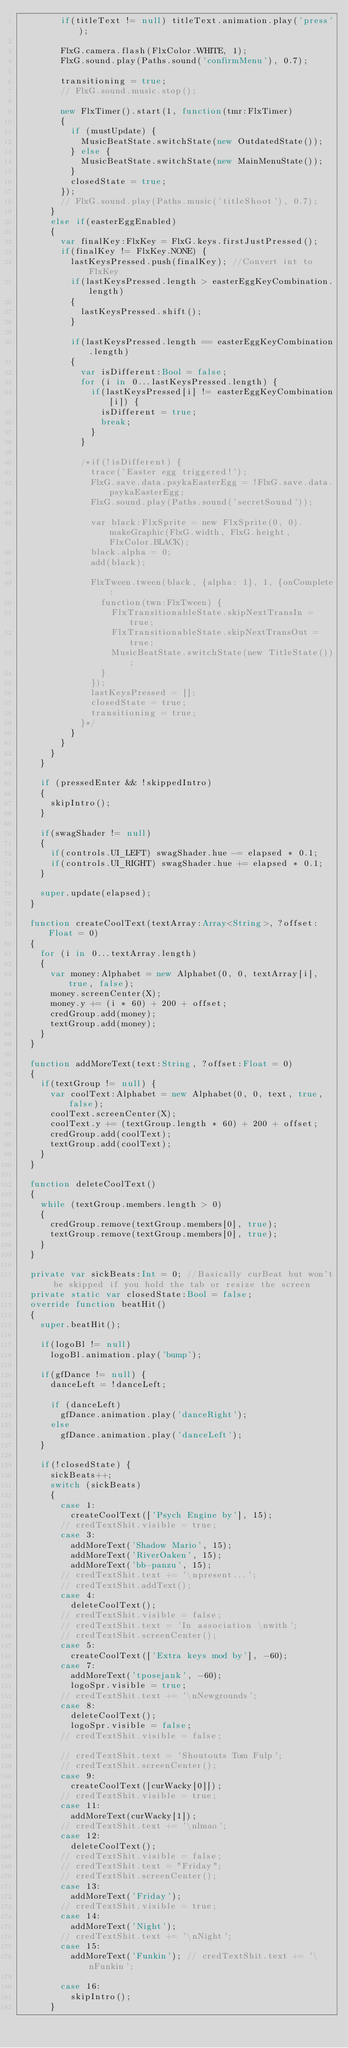<code> <loc_0><loc_0><loc_500><loc_500><_Haxe_>				if(titleText != null) titleText.animation.play('press');

				FlxG.camera.flash(FlxColor.WHITE, 1);
				FlxG.sound.play(Paths.sound('confirmMenu'), 0.7);

				transitioning = true;
				// FlxG.sound.music.stop();

				new FlxTimer().start(1, function(tmr:FlxTimer)
				{
					if (mustUpdate) {
						MusicBeatState.switchState(new OutdatedState());
					} else {
						MusicBeatState.switchState(new MainMenuState());
					}
					closedState = true;
				});
				// FlxG.sound.play(Paths.music('titleShoot'), 0.7);
			}
			else if(easterEggEnabled)
			{
				var finalKey:FlxKey = FlxG.keys.firstJustPressed();
				if(finalKey != FlxKey.NONE) {
					lastKeysPressed.push(finalKey); //Convert int to FlxKey
					if(lastKeysPressed.length > easterEggKeyCombination.length)
					{
						lastKeysPressed.shift();
					}
					
					if(lastKeysPressed.length == easterEggKeyCombination.length)
					{
						var isDifferent:Bool = false;
						for (i in 0...lastKeysPressed.length) {
							if(lastKeysPressed[i] != easterEggKeyCombination[i]) {
								isDifferent = true;
								break;
							}
						}

						/*if(!isDifferent) {
							trace('Easter egg triggered!');
							FlxG.save.data.psykaEasterEgg = !FlxG.save.data.psykaEasterEgg;
							FlxG.sound.play(Paths.sound('secretSound'));

							var black:FlxSprite = new FlxSprite(0, 0).makeGraphic(FlxG.width, FlxG.height, FlxColor.BLACK);
							black.alpha = 0;
							add(black);

							FlxTween.tween(black, {alpha: 1}, 1, {onComplete:
								function(twn:FlxTween) {
									FlxTransitionableState.skipNextTransIn = true;
									FlxTransitionableState.skipNextTransOut = true;
									MusicBeatState.switchState(new TitleState());
								}
							});
							lastKeysPressed = [];
							closedState = true;
							transitioning = true;
						}*/
					}
				}
			}
		}

		if (pressedEnter && !skippedIntro)
		{
			skipIntro();
		}

		if(swagShader != null)
		{
			if(controls.UI_LEFT) swagShader.hue -= elapsed * 0.1;
			if(controls.UI_RIGHT) swagShader.hue += elapsed * 0.1;
		}

		super.update(elapsed);
	}

	function createCoolText(textArray:Array<String>, ?offset:Float = 0)
	{
		for (i in 0...textArray.length)
		{
			var money:Alphabet = new Alphabet(0, 0, textArray[i], true, false);
			money.screenCenter(X);
			money.y += (i * 60) + 200 + offset;
			credGroup.add(money);
			textGroup.add(money);
		}
	}

	function addMoreText(text:String, ?offset:Float = 0)
	{
		if(textGroup != null) {
			var coolText:Alphabet = new Alphabet(0, 0, text, true, false);
			coolText.screenCenter(X);
			coolText.y += (textGroup.length * 60) + 200 + offset;
			credGroup.add(coolText);
			textGroup.add(coolText);
		}
	}

	function deleteCoolText()
	{
		while (textGroup.members.length > 0)
		{
			credGroup.remove(textGroup.members[0], true);
			textGroup.remove(textGroup.members[0], true);
		}
	}

	private var sickBeats:Int = 0; //Basically curBeat but won't be skipped if you hold the tab or resize the screen
	private static var closedState:Bool = false;
	override function beatHit()
	{
		super.beatHit();

		if(logoBl != null) 
			logoBl.animation.play('bump');

		if(gfDance != null) {
			danceLeft = !danceLeft;

			if (danceLeft)
				gfDance.animation.play('danceRight');
			else
				gfDance.animation.play('danceLeft');
		}

		if(!closedState) {
			sickBeats++;
			switch (sickBeats)
			{
				case 1:
					createCoolText(['Psych Engine by'], 15);
				// credTextShit.visible = true;
				case 3:
					addMoreText('Shadow Mario', 15);
					addMoreText('RiverOaken', 15);
					addMoreText('bb-panzu', 15);
				// credTextShit.text += '\npresent...';
				// credTextShit.addText();
				case 4:
					deleteCoolText();
				// credTextShit.visible = false;
				// credTextShit.text = 'In association \nwith';
				// credTextShit.screenCenter();
				case 5:
					createCoolText(['Extra keys mod by'], -60);
				case 7:
					addMoreText('tposejank', -60);
					logoSpr.visible = true;
				// credTextShit.text += '\nNewgrounds';
				case 8:
					deleteCoolText();
					logoSpr.visible = false;
				// credTextShit.visible = false;

				// credTextShit.text = 'Shoutouts Tom Fulp';
				// credTextShit.screenCenter();
				case 9:
					createCoolText([curWacky[0]]);
				// credTextShit.visible = true;
				case 11:
					addMoreText(curWacky[1]);
				// credTextShit.text += '\nlmao';
				case 12:
					deleteCoolText();
				// credTextShit.visible = false;
				// credTextShit.text = "Friday";
				// credTextShit.screenCenter();
				case 13:
					addMoreText('Friday');
				// credTextShit.visible = true;
				case 14:
					addMoreText('Night');
				// credTextShit.text += '\nNight';
				case 15:
					addMoreText('Funkin'); // credTextShit.text += '\nFunkin';

				case 16:
					skipIntro();
			}</code> 